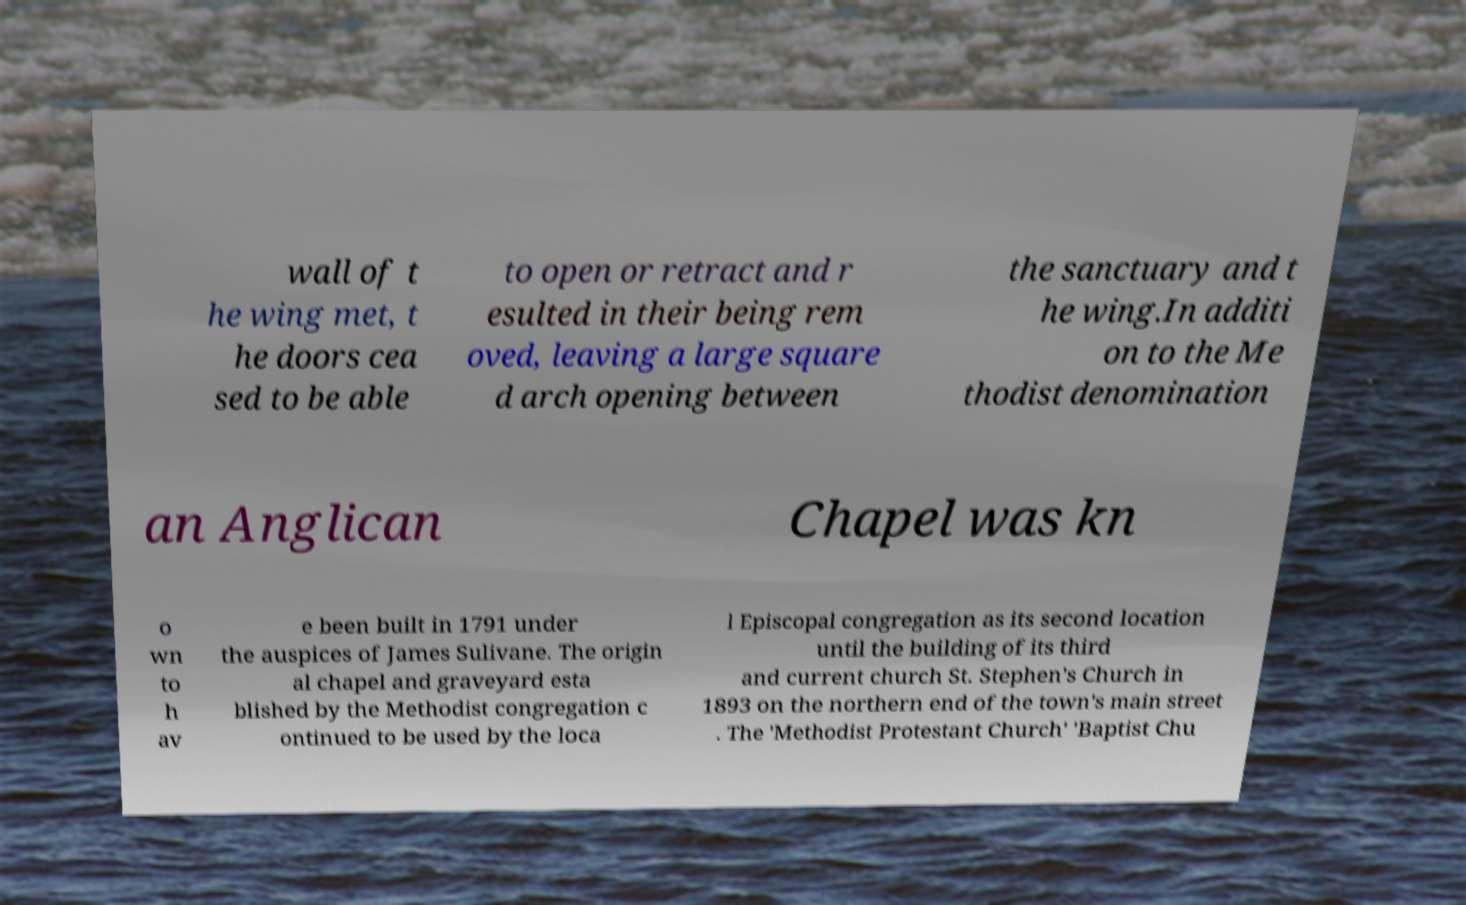Can you accurately transcribe the text from the provided image for me? wall of t he wing met, t he doors cea sed to be able to open or retract and r esulted in their being rem oved, leaving a large square d arch opening between the sanctuary and t he wing.In additi on to the Me thodist denomination an Anglican Chapel was kn o wn to h av e been built in 1791 under the auspices of James Sulivane. The origin al chapel and graveyard esta blished by the Methodist congregation c ontinued to be used by the loca l Episcopal congregation as its second location until the building of its third and current church St. Stephen's Church in 1893 on the northern end of the town's main street . The 'Methodist Protestant Church' 'Baptist Chu 